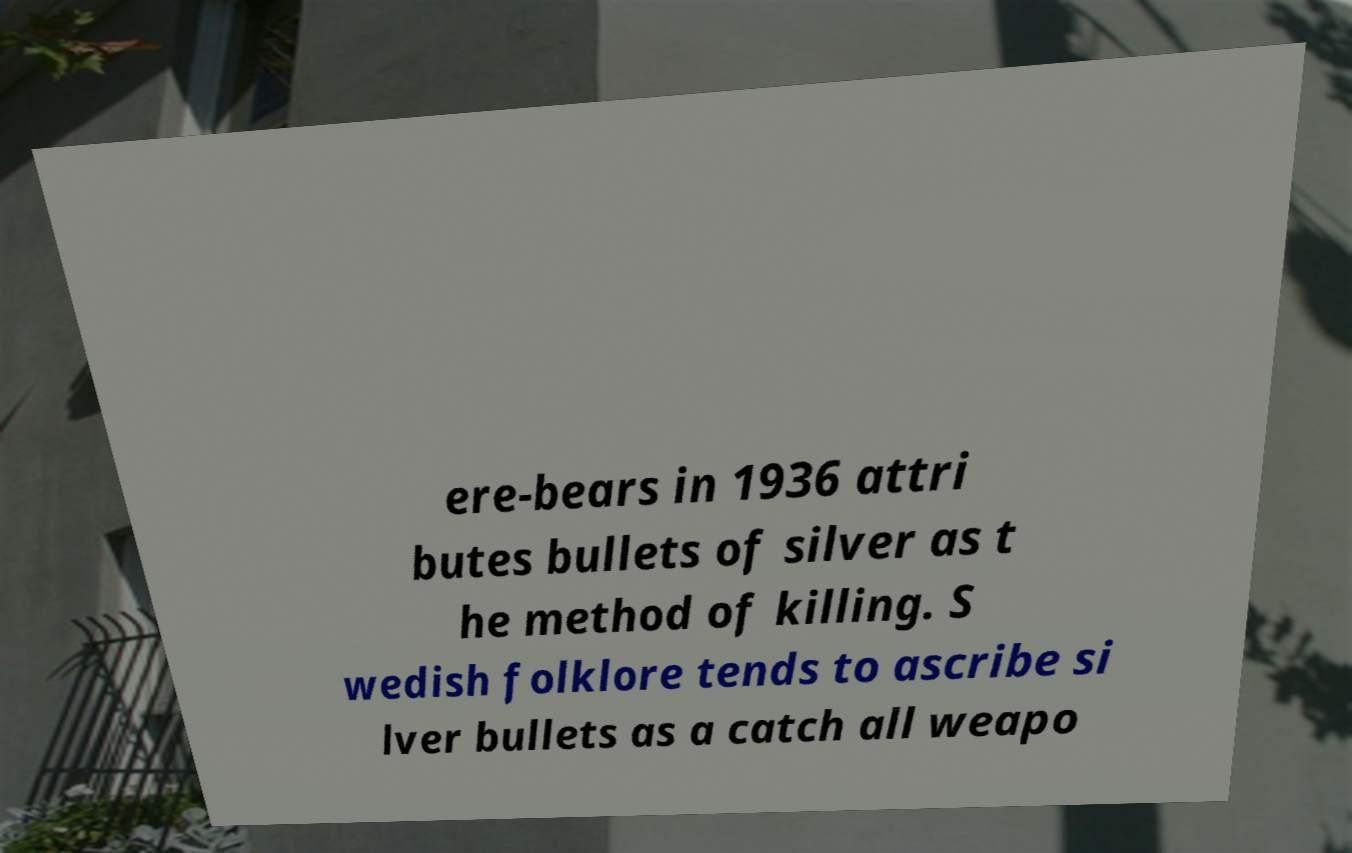There's text embedded in this image that I need extracted. Can you transcribe it verbatim? ere-bears in 1936 attri butes bullets of silver as t he method of killing. S wedish folklore tends to ascribe si lver bullets as a catch all weapo 